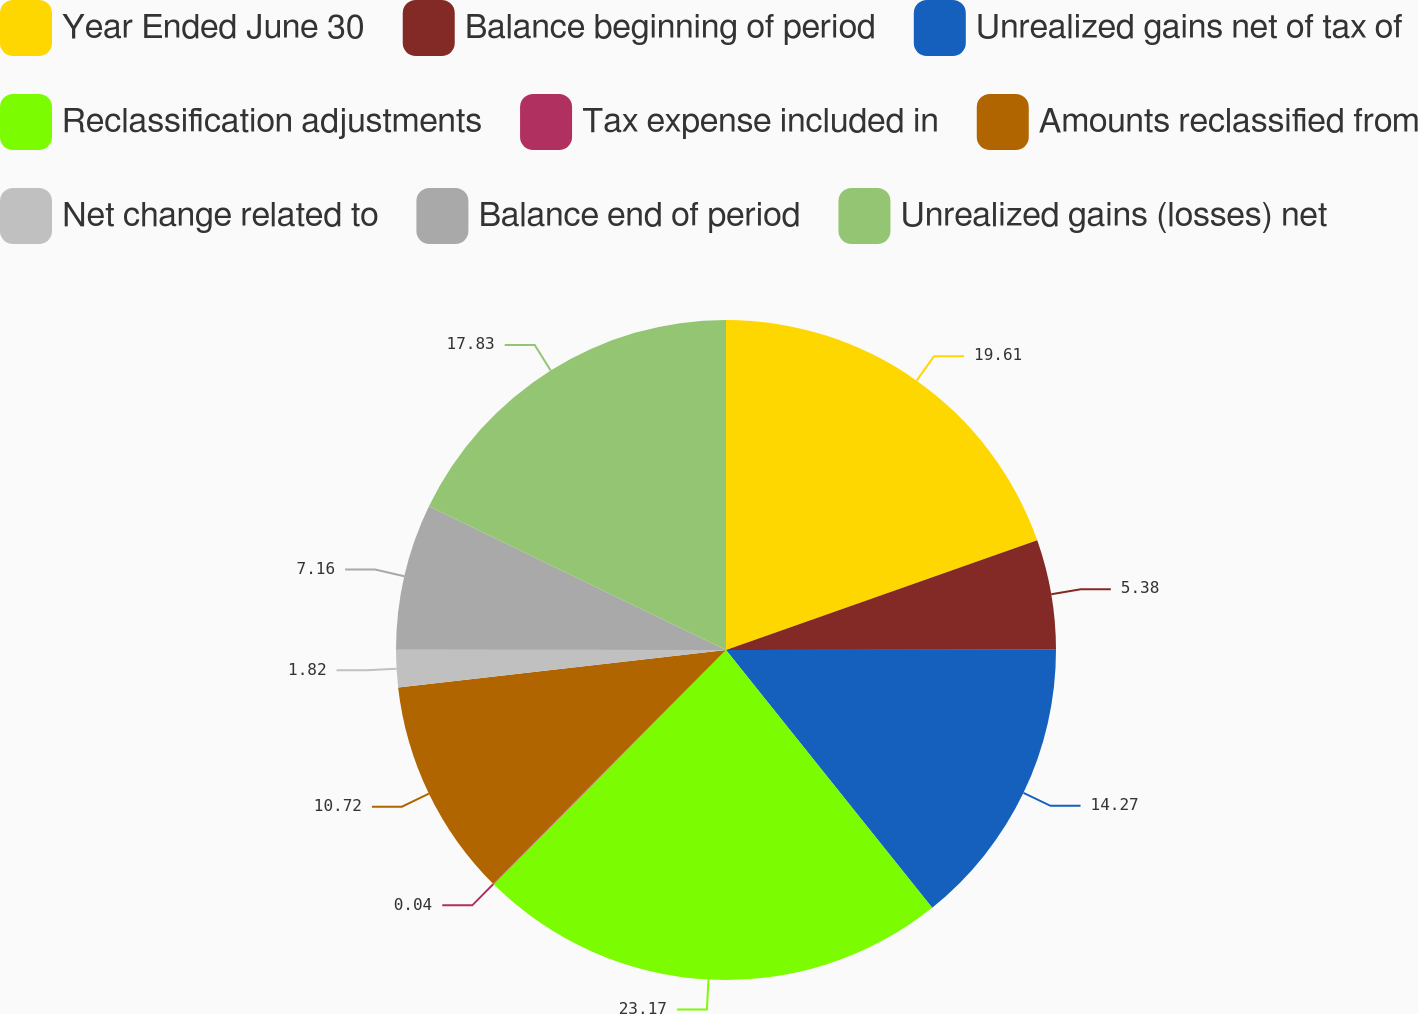Convert chart to OTSL. <chart><loc_0><loc_0><loc_500><loc_500><pie_chart><fcel>Year Ended June 30<fcel>Balance beginning of period<fcel>Unrealized gains net of tax of<fcel>Reclassification adjustments<fcel>Tax expense included in<fcel>Amounts reclassified from<fcel>Net change related to<fcel>Balance end of period<fcel>Unrealized gains (losses) net<nl><fcel>19.61%<fcel>5.38%<fcel>14.27%<fcel>23.17%<fcel>0.04%<fcel>10.72%<fcel>1.82%<fcel>7.16%<fcel>17.83%<nl></chart> 